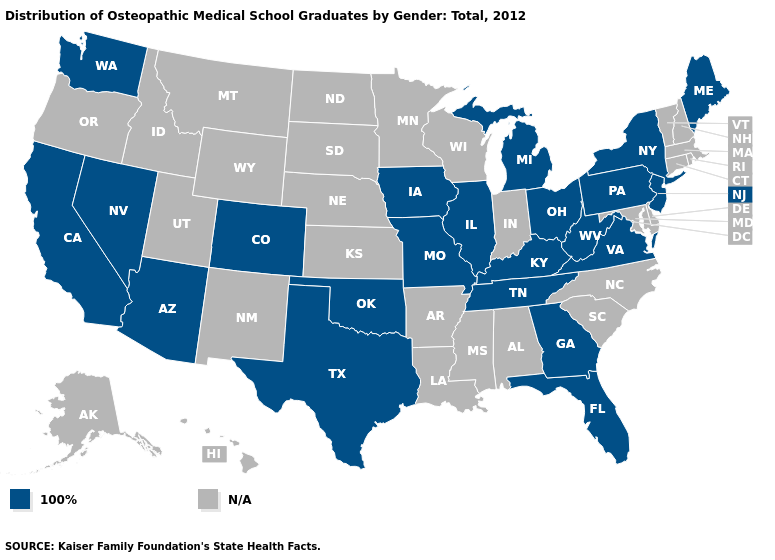How many symbols are there in the legend?
Be succinct. 2. What is the value of Indiana?
Be succinct. N/A. What is the lowest value in the West?
Short answer required. 100%. What is the value of Vermont?
Short answer required. N/A. Is the legend a continuous bar?
Be succinct. No. What is the lowest value in the USA?
Quick response, please. 100%. Does the first symbol in the legend represent the smallest category?
Concise answer only. Yes. What is the value of Tennessee?
Quick response, please. 100%. What is the value of California?
Quick response, please. 100%. What is the value of Utah?
Short answer required. N/A. What is the highest value in the South ?
Give a very brief answer. 100%. What is the value of California?
Short answer required. 100%. What is the lowest value in the West?
Quick response, please. 100%. 